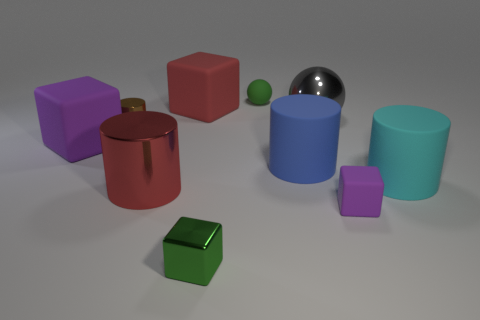Subtract 3 blocks. How many blocks are left? 1 Subtract all red shiny cylinders. How many cylinders are left? 3 Subtract all red cubes. Subtract all brown spheres. How many cubes are left? 3 Subtract all green blocks. How many blocks are left? 3 Subtract 0 cyan blocks. How many objects are left? 10 Subtract all cubes. How many objects are left? 6 Subtract all blue blocks. How many purple cylinders are left? 0 Subtract all purple rubber objects. Subtract all big gray balls. How many objects are left? 7 Add 4 big red matte blocks. How many big red matte blocks are left? 5 Add 4 big gray cylinders. How many big gray cylinders exist? 4 